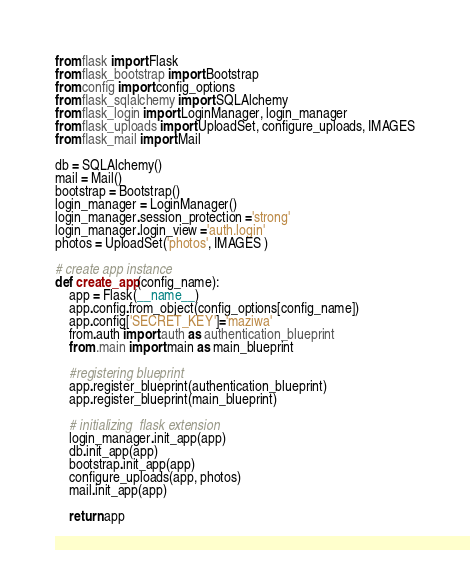Convert code to text. <code><loc_0><loc_0><loc_500><loc_500><_Python_>from flask import Flask
from flask_bootstrap import Bootstrap
from config import config_options
from flask_sqlalchemy import SQLAlchemy
from flask_login import LoginManager, login_manager
from flask_uploads import UploadSet, configure_uploads, IMAGES
from flask_mail import Mail

db = SQLAlchemy()
mail = Mail()
bootstrap = Bootstrap()
login_manager = LoginManager()
login_manager.session_protection ='strong'
login_manager.login_view ='auth.login'
photos = UploadSet('photos', IMAGES )

# create app instance
def create_app(config_name):
    app = Flask(__name__)
    app.config.from_object(config_options[config_name])
    app.config['SECRET_KEY']='maziwa'
    from.auth import auth as authentication_blueprint
    from .main import main as main_blueprint

    #registering blueprint
    app.register_blueprint(authentication_blueprint)
    app.register_blueprint(main_blueprint)

    # initializing  flask extension
    login_manager.init_app(app)
    db.init_app(app)
    bootstrap.init_app(app)
    configure_uploads(app, photos)
    mail.init_app(app)

    return app
</code> 